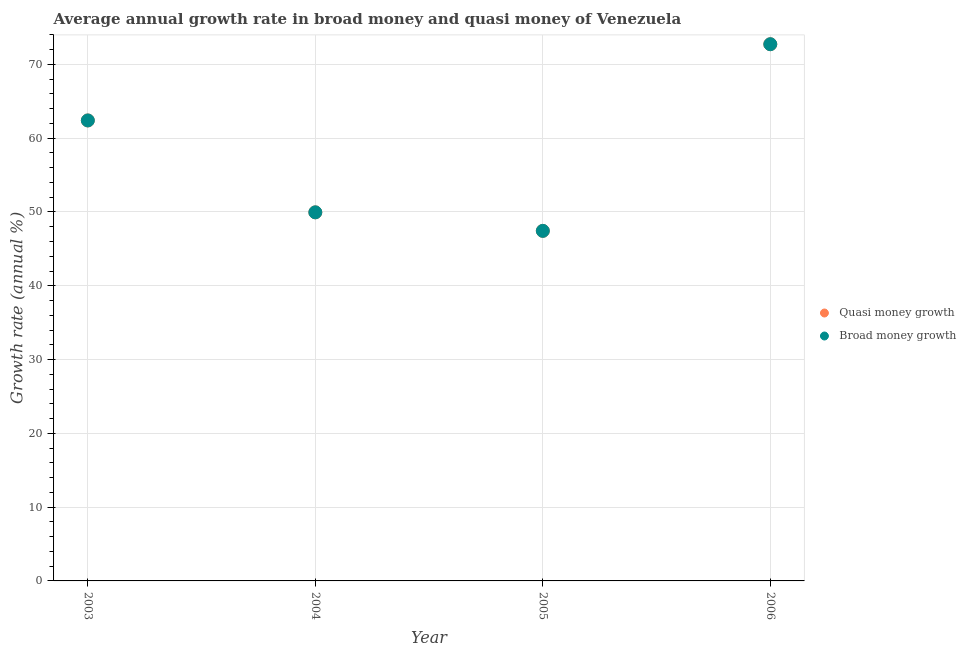Is the number of dotlines equal to the number of legend labels?
Give a very brief answer. Yes. What is the annual growth rate in quasi money in 2004?
Offer a very short reply. 49.95. Across all years, what is the maximum annual growth rate in quasi money?
Keep it short and to the point. 72.74. Across all years, what is the minimum annual growth rate in quasi money?
Your response must be concise. 47.44. In which year was the annual growth rate in broad money maximum?
Offer a very short reply. 2006. In which year was the annual growth rate in quasi money minimum?
Provide a succinct answer. 2005. What is the total annual growth rate in quasi money in the graph?
Keep it short and to the point. 232.53. What is the difference between the annual growth rate in quasi money in 2004 and that in 2005?
Offer a very short reply. 2.51. What is the difference between the annual growth rate in broad money in 2006 and the annual growth rate in quasi money in 2005?
Your response must be concise. 25.3. What is the average annual growth rate in broad money per year?
Offer a very short reply. 58.13. In the year 2003, what is the difference between the annual growth rate in broad money and annual growth rate in quasi money?
Offer a terse response. 0. What is the ratio of the annual growth rate in broad money in 2005 to that in 2006?
Provide a succinct answer. 0.65. Is the annual growth rate in quasi money in 2005 less than that in 2006?
Your answer should be compact. Yes. What is the difference between the highest and the second highest annual growth rate in quasi money?
Offer a terse response. 10.33. What is the difference between the highest and the lowest annual growth rate in broad money?
Your answer should be compact. 25.3. Is the sum of the annual growth rate in quasi money in 2003 and 2005 greater than the maximum annual growth rate in broad money across all years?
Your response must be concise. Yes. Is the annual growth rate in broad money strictly greater than the annual growth rate in quasi money over the years?
Give a very brief answer. No. How many dotlines are there?
Provide a succinct answer. 2. How many years are there in the graph?
Ensure brevity in your answer.  4. What is the difference between two consecutive major ticks on the Y-axis?
Your answer should be very brief. 10. Does the graph contain any zero values?
Provide a succinct answer. No. Where does the legend appear in the graph?
Keep it short and to the point. Center right. How many legend labels are there?
Keep it short and to the point. 2. What is the title of the graph?
Provide a short and direct response. Average annual growth rate in broad money and quasi money of Venezuela. Does "Total Population" appear as one of the legend labels in the graph?
Provide a short and direct response. No. What is the label or title of the Y-axis?
Offer a very short reply. Growth rate (annual %). What is the Growth rate (annual %) of Quasi money growth in 2003?
Offer a very short reply. 62.41. What is the Growth rate (annual %) in Broad money growth in 2003?
Provide a succinct answer. 62.41. What is the Growth rate (annual %) in Quasi money growth in 2004?
Your answer should be very brief. 49.95. What is the Growth rate (annual %) in Broad money growth in 2004?
Offer a very short reply. 49.95. What is the Growth rate (annual %) of Quasi money growth in 2005?
Give a very brief answer. 47.44. What is the Growth rate (annual %) in Broad money growth in 2005?
Provide a succinct answer. 47.44. What is the Growth rate (annual %) in Quasi money growth in 2006?
Keep it short and to the point. 72.74. What is the Growth rate (annual %) in Broad money growth in 2006?
Offer a very short reply. 72.74. Across all years, what is the maximum Growth rate (annual %) of Quasi money growth?
Your response must be concise. 72.74. Across all years, what is the maximum Growth rate (annual %) of Broad money growth?
Keep it short and to the point. 72.74. Across all years, what is the minimum Growth rate (annual %) of Quasi money growth?
Offer a very short reply. 47.44. Across all years, what is the minimum Growth rate (annual %) of Broad money growth?
Keep it short and to the point. 47.44. What is the total Growth rate (annual %) of Quasi money growth in the graph?
Provide a short and direct response. 232.53. What is the total Growth rate (annual %) of Broad money growth in the graph?
Make the answer very short. 232.53. What is the difference between the Growth rate (annual %) of Quasi money growth in 2003 and that in 2004?
Offer a terse response. 12.45. What is the difference between the Growth rate (annual %) in Broad money growth in 2003 and that in 2004?
Offer a very short reply. 12.45. What is the difference between the Growth rate (annual %) in Quasi money growth in 2003 and that in 2005?
Ensure brevity in your answer.  14.97. What is the difference between the Growth rate (annual %) in Broad money growth in 2003 and that in 2005?
Offer a terse response. 14.97. What is the difference between the Growth rate (annual %) in Quasi money growth in 2003 and that in 2006?
Make the answer very short. -10.33. What is the difference between the Growth rate (annual %) in Broad money growth in 2003 and that in 2006?
Provide a succinct answer. -10.33. What is the difference between the Growth rate (annual %) in Quasi money growth in 2004 and that in 2005?
Offer a very short reply. 2.51. What is the difference between the Growth rate (annual %) of Broad money growth in 2004 and that in 2005?
Make the answer very short. 2.51. What is the difference between the Growth rate (annual %) of Quasi money growth in 2004 and that in 2006?
Offer a very short reply. -22.78. What is the difference between the Growth rate (annual %) of Broad money growth in 2004 and that in 2006?
Your answer should be very brief. -22.78. What is the difference between the Growth rate (annual %) of Quasi money growth in 2005 and that in 2006?
Offer a very short reply. -25.3. What is the difference between the Growth rate (annual %) of Broad money growth in 2005 and that in 2006?
Offer a terse response. -25.3. What is the difference between the Growth rate (annual %) of Quasi money growth in 2003 and the Growth rate (annual %) of Broad money growth in 2004?
Your answer should be very brief. 12.45. What is the difference between the Growth rate (annual %) in Quasi money growth in 2003 and the Growth rate (annual %) in Broad money growth in 2005?
Provide a short and direct response. 14.97. What is the difference between the Growth rate (annual %) of Quasi money growth in 2003 and the Growth rate (annual %) of Broad money growth in 2006?
Your response must be concise. -10.33. What is the difference between the Growth rate (annual %) in Quasi money growth in 2004 and the Growth rate (annual %) in Broad money growth in 2005?
Your answer should be compact. 2.51. What is the difference between the Growth rate (annual %) in Quasi money growth in 2004 and the Growth rate (annual %) in Broad money growth in 2006?
Your answer should be compact. -22.78. What is the difference between the Growth rate (annual %) in Quasi money growth in 2005 and the Growth rate (annual %) in Broad money growth in 2006?
Provide a short and direct response. -25.3. What is the average Growth rate (annual %) of Quasi money growth per year?
Your response must be concise. 58.13. What is the average Growth rate (annual %) in Broad money growth per year?
Offer a very short reply. 58.13. In the year 2003, what is the difference between the Growth rate (annual %) of Quasi money growth and Growth rate (annual %) of Broad money growth?
Your answer should be compact. 0. In the year 2004, what is the difference between the Growth rate (annual %) in Quasi money growth and Growth rate (annual %) in Broad money growth?
Your response must be concise. 0. In the year 2005, what is the difference between the Growth rate (annual %) of Quasi money growth and Growth rate (annual %) of Broad money growth?
Offer a very short reply. 0. In the year 2006, what is the difference between the Growth rate (annual %) in Quasi money growth and Growth rate (annual %) in Broad money growth?
Offer a terse response. 0. What is the ratio of the Growth rate (annual %) of Quasi money growth in 2003 to that in 2004?
Offer a terse response. 1.25. What is the ratio of the Growth rate (annual %) in Broad money growth in 2003 to that in 2004?
Provide a short and direct response. 1.25. What is the ratio of the Growth rate (annual %) of Quasi money growth in 2003 to that in 2005?
Your answer should be very brief. 1.32. What is the ratio of the Growth rate (annual %) in Broad money growth in 2003 to that in 2005?
Your response must be concise. 1.32. What is the ratio of the Growth rate (annual %) of Quasi money growth in 2003 to that in 2006?
Give a very brief answer. 0.86. What is the ratio of the Growth rate (annual %) in Broad money growth in 2003 to that in 2006?
Ensure brevity in your answer.  0.86. What is the ratio of the Growth rate (annual %) of Quasi money growth in 2004 to that in 2005?
Make the answer very short. 1.05. What is the ratio of the Growth rate (annual %) of Broad money growth in 2004 to that in 2005?
Keep it short and to the point. 1.05. What is the ratio of the Growth rate (annual %) of Quasi money growth in 2004 to that in 2006?
Offer a terse response. 0.69. What is the ratio of the Growth rate (annual %) of Broad money growth in 2004 to that in 2006?
Make the answer very short. 0.69. What is the ratio of the Growth rate (annual %) in Quasi money growth in 2005 to that in 2006?
Make the answer very short. 0.65. What is the ratio of the Growth rate (annual %) of Broad money growth in 2005 to that in 2006?
Your answer should be very brief. 0.65. What is the difference between the highest and the second highest Growth rate (annual %) of Quasi money growth?
Keep it short and to the point. 10.33. What is the difference between the highest and the second highest Growth rate (annual %) of Broad money growth?
Ensure brevity in your answer.  10.33. What is the difference between the highest and the lowest Growth rate (annual %) in Quasi money growth?
Ensure brevity in your answer.  25.3. What is the difference between the highest and the lowest Growth rate (annual %) of Broad money growth?
Make the answer very short. 25.3. 